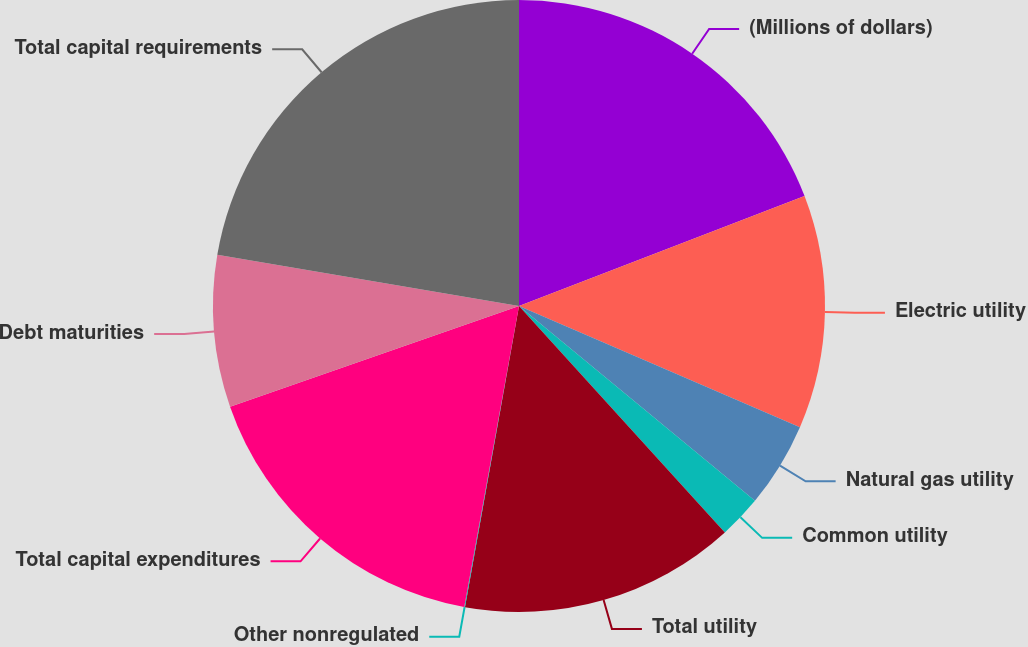Convert chart. <chart><loc_0><loc_0><loc_500><loc_500><pie_chart><fcel>(Millions of dollars)<fcel>Electric utility<fcel>Natural gas utility<fcel>Common utility<fcel>Total utility<fcel>Other nonregulated<fcel>Total capital expenditures<fcel>Debt maturities<fcel>Total capital requirements<nl><fcel>19.15%<fcel>12.34%<fcel>4.5%<fcel>2.27%<fcel>14.57%<fcel>0.04%<fcel>16.8%<fcel>8.01%<fcel>22.33%<nl></chart> 